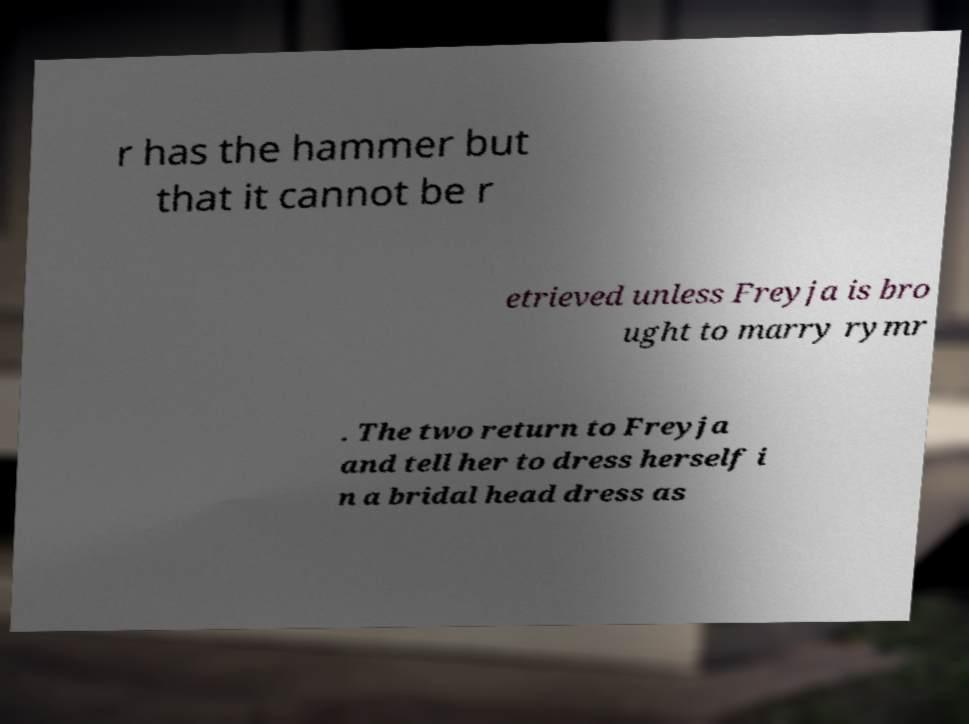Please read and relay the text visible in this image. What does it say? r has the hammer but that it cannot be r etrieved unless Freyja is bro ught to marry rymr . The two return to Freyja and tell her to dress herself i n a bridal head dress as 